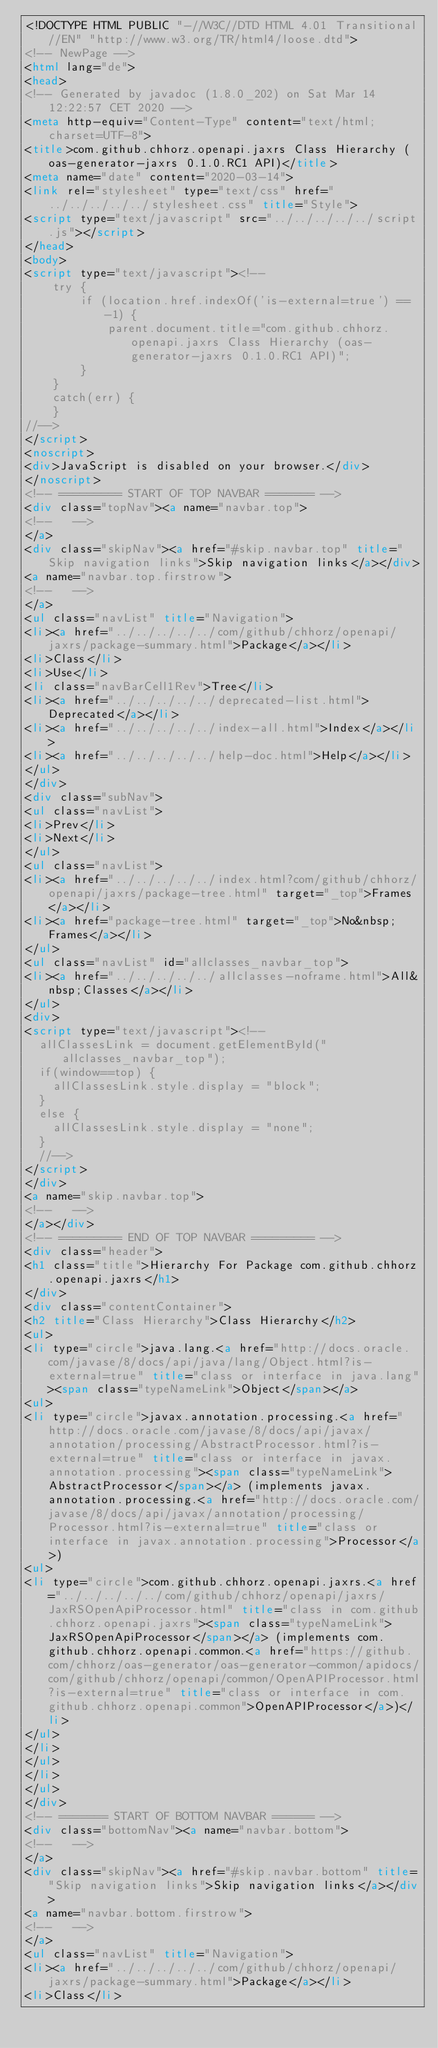<code> <loc_0><loc_0><loc_500><loc_500><_HTML_><!DOCTYPE HTML PUBLIC "-//W3C//DTD HTML 4.01 Transitional//EN" "http://www.w3.org/TR/html4/loose.dtd">
<!-- NewPage -->
<html lang="de">
<head>
<!-- Generated by javadoc (1.8.0_202) on Sat Mar 14 12:22:57 CET 2020 -->
<meta http-equiv="Content-Type" content="text/html; charset=UTF-8">
<title>com.github.chhorz.openapi.jaxrs Class Hierarchy (oas-generator-jaxrs 0.1.0.RC1 API)</title>
<meta name="date" content="2020-03-14">
<link rel="stylesheet" type="text/css" href="../../../../../stylesheet.css" title="Style">
<script type="text/javascript" src="../../../../../script.js"></script>
</head>
<body>
<script type="text/javascript"><!--
    try {
        if (location.href.indexOf('is-external=true') == -1) {
            parent.document.title="com.github.chhorz.openapi.jaxrs Class Hierarchy (oas-generator-jaxrs 0.1.0.RC1 API)";
        }
    }
    catch(err) {
    }
//-->
</script>
<noscript>
<div>JavaScript is disabled on your browser.</div>
</noscript>
<!-- ========= START OF TOP NAVBAR ======= -->
<div class="topNav"><a name="navbar.top">
<!--   -->
</a>
<div class="skipNav"><a href="#skip.navbar.top" title="Skip navigation links">Skip navigation links</a></div>
<a name="navbar.top.firstrow">
<!--   -->
</a>
<ul class="navList" title="Navigation">
<li><a href="../../../../../com/github/chhorz/openapi/jaxrs/package-summary.html">Package</a></li>
<li>Class</li>
<li>Use</li>
<li class="navBarCell1Rev">Tree</li>
<li><a href="../../../../../deprecated-list.html">Deprecated</a></li>
<li><a href="../../../../../index-all.html">Index</a></li>
<li><a href="../../../../../help-doc.html">Help</a></li>
</ul>
</div>
<div class="subNav">
<ul class="navList">
<li>Prev</li>
<li>Next</li>
</ul>
<ul class="navList">
<li><a href="../../../../../index.html?com/github/chhorz/openapi/jaxrs/package-tree.html" target="_top">Frames</a></li>
<li><a href="package-tree.html" target="_top">No&nbsp;Frames</a></li>
</ul>
<ul class="navList" id="allclasses_navbar_top">
<li><a href="../../../../../allclasses-noframe.html">All&nbsp;Classes</a></li>
</ul>
<div>
<script type="text/javascript"><!--
  allClassesLink = document.getElementById("allclasses_navbar_top");
  if(window==top) {
    allClassesLink.style.display = "block";
  }
  else {
    allClassesLink.style.display = "none";
  }
  //-->
</script>
</div>
<a name="skip.navbar.top">
<!--   -->
</a></div>
<!-- ========= END OF TOP NAVBAR ========= -->
<div class="header">
<h1 class="title">Hierarchy For Package com.github.chhorz.openapi.jaxrs</h1>
</div>
<div class="contentContainer">
<h2 title="Class Hierarchy">Class Hierarchy</h2>
<ul>
<li type="circle">java.lang.<a href="http://docs.oracle.com/javase/8/docs/api/java/lang/Object.html?is-external=true" title="class or interface in java.lang"><span class="typeNameLink">Object</span></a>
<ul>
<li type="circle">javax.annotation.processing.<a href="http://docs.oracle.com/javase/8/docs/api/javax/annotation/processing/AbstractProcessor.html?is-external=true" title="class or interface in javax.annotation.processing"><span class="typeNameLink">AbstractProcessor</span></a> (implements javax.annotation.processing.<a href="http://docs.oracle.com/javase/8/docs/api/javax/annotation/processing/Processor.html?is-external=true" title="class or interface in javax.annotation.processing">Processor</a>)
<ul>
<li type="circle">com.github.chhorz.openapi.jaxrs.<a href="../../../../../com/github/chhorz/openapi/jaxrs/JaxRSOpenApiProcessor.html" title="class in com.github.chhorz.openapi.jaxrs"><span class="typeNameLink">JaxRSOpenApiProcessor</span></a> (implements com.github.chhorz.openapi.common.<a href="https://github.com/chhorz/oas-generator/oas-generator-common/apidocs/com/github/chhorz/openapi/common/OpenAPIProcessor.html?is-external=true" title="class or interface in com.github.chhorz.openapi.common">OpenAPIProcessor</a>)</li>
</ul>
</li>
</ul>
</li>
</ul>
</div>
<!-- ======= START OF BOTTOM NAVBAR ====== -->
<div class="bottomNav"><a name="navbar.bottom">
<!--   -->
</a>
<div class="skipNav"><a href="#skip.navbar.bottom" title="Skip navigation links">Skip navigation links</a></div>
<a name="navbar.bottom.firstrow">
<!--   -->
</a>
<ul class="navList" title="Navigation">
<li><a href="../../../../../com/github/chhorz/openapi/jaxrs/package-summary.html">Package</a></li>
<li>Class</li></code> 